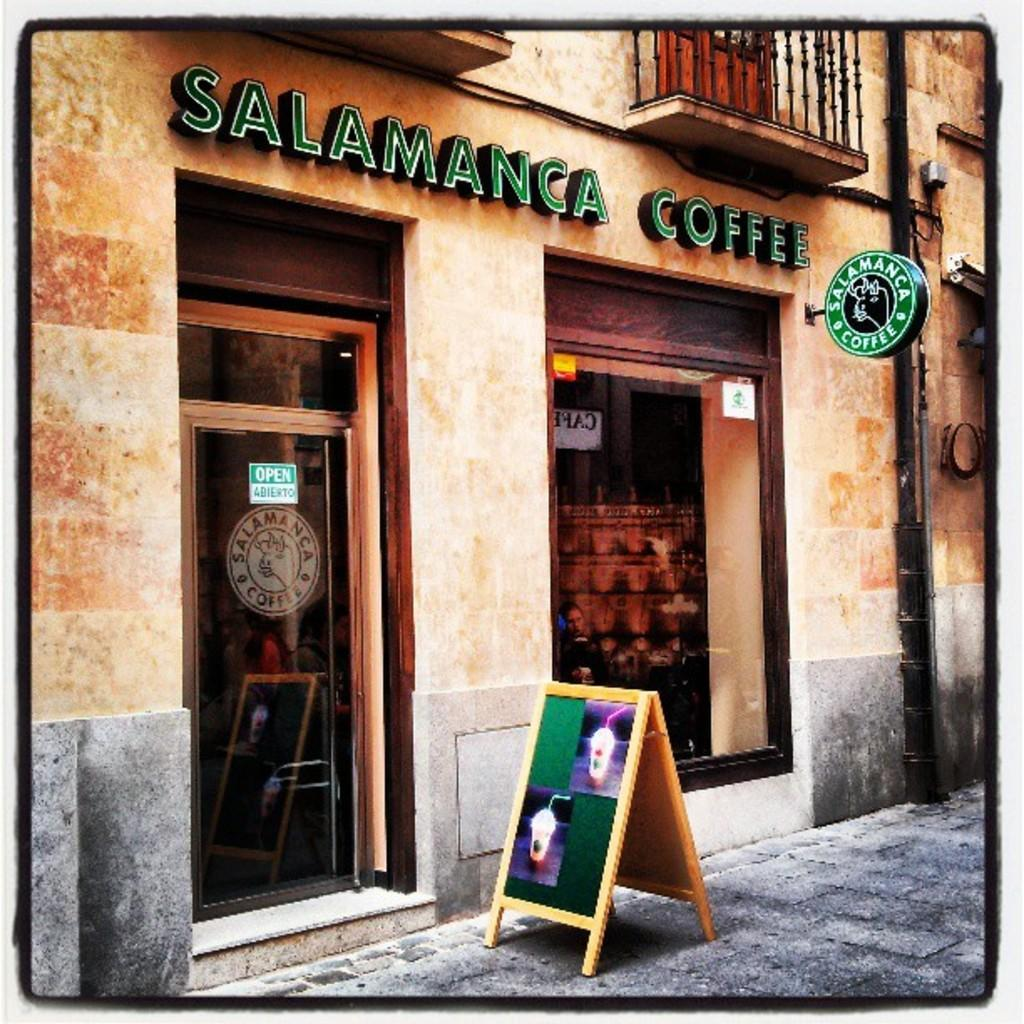<image>
Summarize the visual content of the image. A store selling Salamanca Coffee and a sidewalk sign showing two different coffees loaded with whip topping and straws. 